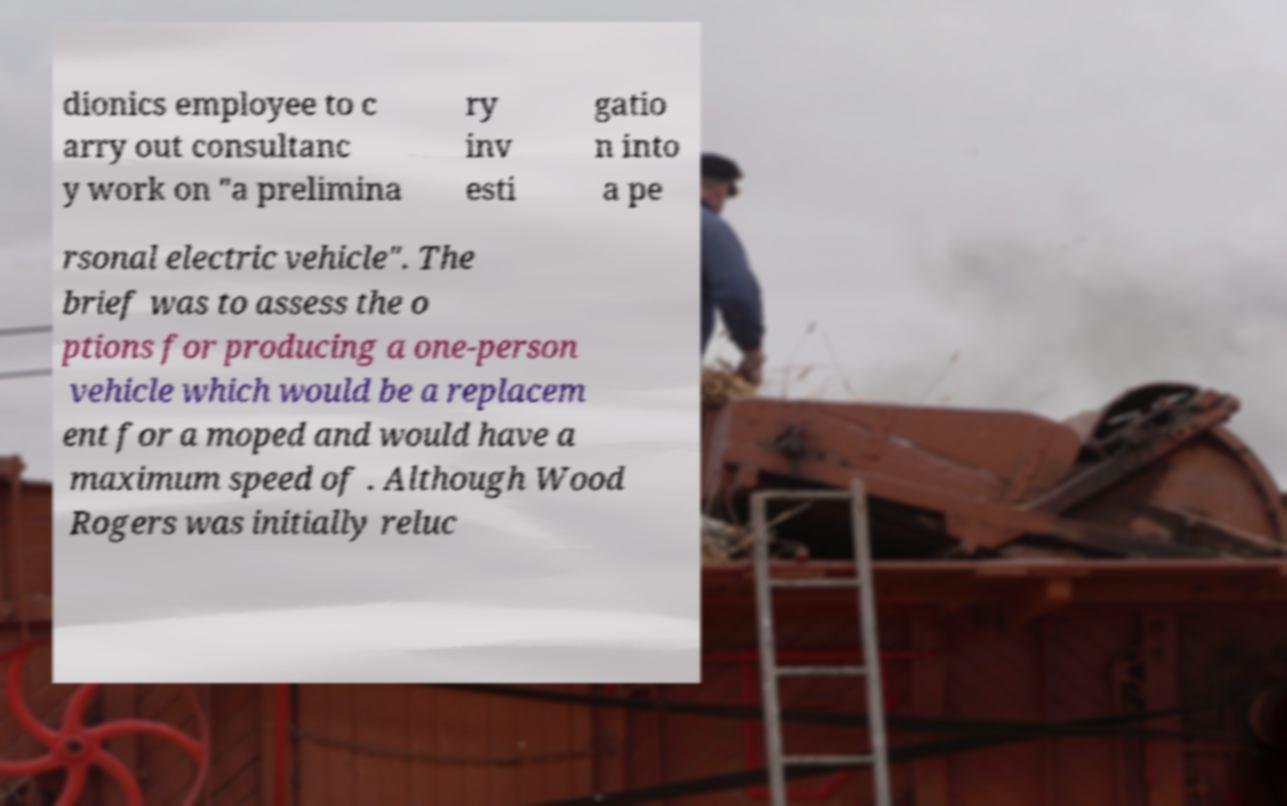Can you read and provide the text displayed in the image?This photo seems to have some interesting text. Can you extract and type it out for me? dionics employee to c arry out consultanc y work on "a prelimina ry inv esti gatio n into a pe rsonal electric vehicle". The brief was to assess the o ptions for producing a one-person vehicle which would be a replacem ent for a moped and would have a maximum speed of . Although Wood Rogers was initially reluc 